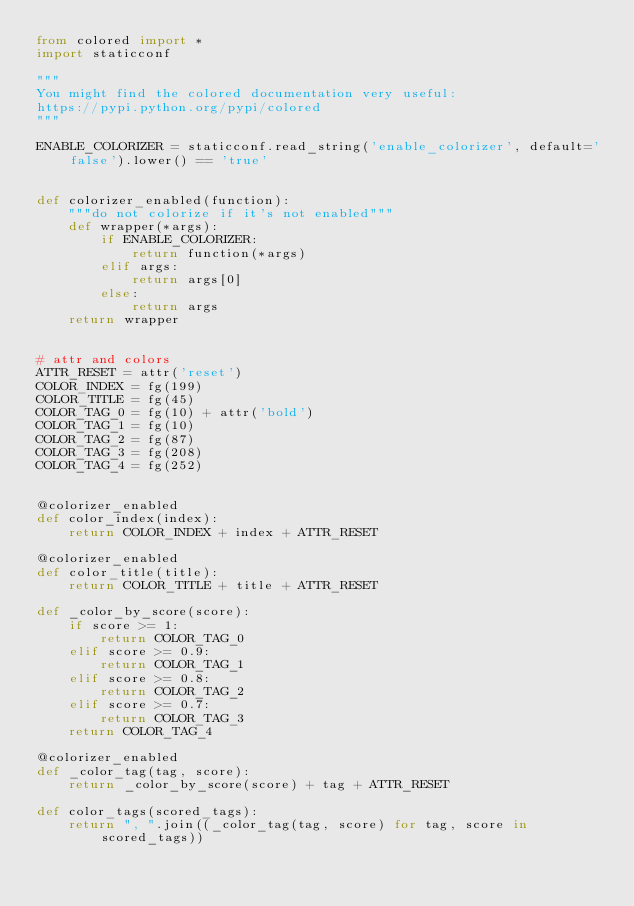Convert code to text. <code><loc_0><loc_0><loc_500><loc_500><_Python_>from colored import *
import staticconf

"""
You might find the colored documentation very useful:
https://pypi.python.org/pypi/colored
"""

ENABLE_COLORIZER = staticconf.read_string('enable_colorizer', default='false').lower() == 'true'


def colorizer_enabled(function):
    """do not colorize if it's not enabled"""
    def wrapper(*args):
        if ENABLE_COLORIZER:
            return function(*args)
        elif args:
            return args[0]
        else:
            return args
    return wrapper


# attr and colors
ATTR_RESET = attr('reset')
COLOR_INDEX = fg(199)
COLOR_TITLE = fg(45)
COLOR_TAG_0 = fg(10) + attr('bold')
COLOR_TAG_1 = fg(10)
COLOR_TAG_2 = fg(87)
COLOR_TAG_3 = fg(208)
COLOR_TAG_4 = fg(252)


@colorizer_enabled
def color_index(index):
    return COLOR_INDEX + index + ATTR_RESET

@colorizer_enabled
def color_title(title):
    return COLOR_TITLE + title + ATTR_RESET

def _color_by_score(score):
    if score >= 1:
        return COLOR_TAG_0
    elif score >= 0.9:
        return COLOR_TAG_1
    elif score >= 0.8:
        return COLOR_TAG_2
    elif score >= 0.7:
        return COLOR_TAG_3
    return COLOR_TAG_4

@colorizer_enabled
def _color_tag(tag, score):
    return _color_by_score(score) + tag + ATTR_RESET

def color_tags(scored_tags):
    return ", ".join((_color_tag(tag, score) for tag, score in scored_tags))
</code> 